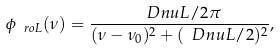<formula> <loc_0><loc_0><loc_500><loc_500>\phi _ { \ r o { L } } ( \nu ) = \frac { \ D n u L / 2 \pi } { ( \nu - \nu _ { 0 } ) ^ { 2 } + ( \ D n u L / 2 ) ^ { 2 } } ,</formula> 